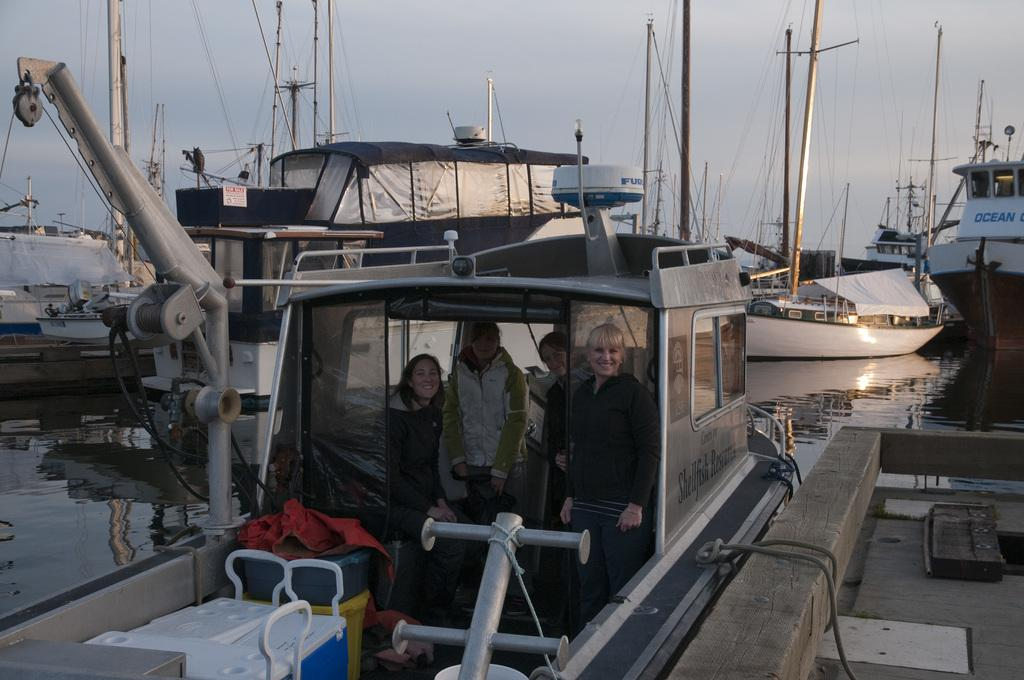What is the main subject of the image? The main subject of the image is people in a boat. Can you describe the surroundings of the boat? There are other boats in the background of the image, and there is water visible at the bottom of the image. What can be seen in the sky in the image? The sky is visible at the top of the image. How many rabbits are sitting on the boat in the image? There are no rabbits present in the image; it features people in a boat. What type of bead is being used to decorate the boat in the image? There is no bead present in the image; it only shows a boat with people in it. 